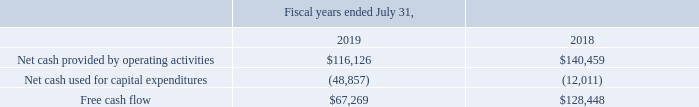Free Cash Flow
We monitor our free cash flow, as a key measure of our overall business performance, which enables us to analyze our financial performance without the effects of certain non-cash items such as depreciation, amortization, and stock-based compensation expenses. Additionally, free cash flow takes into account the impact of changes in deferred revenue, which reflects the receipt of cash payment for products before they are recognized as revenue, and unbilled accounts receivable, which reflects revenue that has been recognized that has yet to be invoiced to our customers.
Our net cash provided by (used in) operating activities is significantly impacted by the timing of invoicing and collections of accounts receivable, the timing and amount of annual bonus payments, as well as payroll and tax payments. Our capital expenditures consisted of purchases of property and equipment, most of which were computer hardware, software, capitalized software development costs, and leasehold improvements.
In fiscal year 2019, free cash flow was impacted by $23.6 million related to the build out and furnishing of our new corporate headquarters in San Mateo, California. For a further discussion of our operating cash flows, see “Liquidity and Capital Resources - Cash Flows.”(in thousands)
What does free cash flow take into account? The impact of changes in deferred revenue, which reflects the receipt of cash payment for products before they are recognized as revenue, and unbilled accounts receivable, which reflects revenue that has been recognized that has yet to be invoiced to our customers. What impacted the net cash provided by (used in) operating activities? The timing of invoicing and collections of accounts receivable, the timing and amount of annual bonus payments, as well as payroll and tax payments. What was the Net cash provided by operating activities in 2019 and 2018 respectively? $116,126, $140,459. In which year was Free cash flow less than 100,000 thousands? Locate and analyze free cash flow in row 5
answer: 2019. What was the average Net cash used for capital expenditures for 2018 and 2019?
Answer scale should be: thousand. -(48,857 + 12,011) / 2
Answer: -30434. What was the change in the Net cash provided by operating activities from 2018 to 2019?
Answer scale should be: thousand. 116,126 - 140,459
Answer: -24333. 